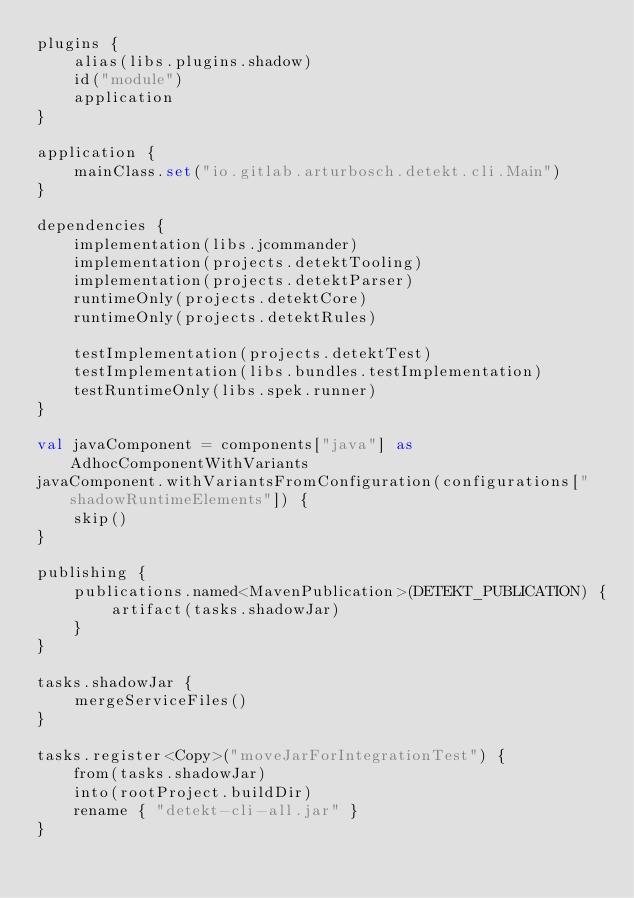Convert code to text. <code><loc_0><loc_0><loc_500><loc_500><_Kotlin_>plugins {
    alias(libs.plugins.shadow)
    id("module")
    application
}

application {
    mainClass.set("io.gitlab.arturbosch.detekt.cli.Main")
}

dependencies {
    implementation(libs.jcommander)
    implementation(projects.detektTooling)
    implementation(projects.detektParser)
    runtimeOnly(projects.detektCore)
    runtimeOnly(projects.detektRules)

    testImplementation(projects.detektTest)
    testImplementation(libs.bundles.testImplementation)
    testRuntimeOnly(libs.spek.runner)
}

val javaComponent = components["java"] as AdhocComponentWithVariants
javaComponent.withVariantsFromConfiguration(configurations["shadowRuntimeElements"]) {
    skip()
}

publishing {
    publications.named<MavenPublication>(DETEKT_PUBLICATION) {
        artifact(tasks.shadowJar)
    }
}

tasks.shadowJar {
    mergeServiceFiles()
}

tasks.register<Copy>("moveJarForIntegrationTest") {
    from(tasks.shadowJar)
    into(rootProject.buildDir)
    rename { "detekt-cli-all.jar" }
}
</code> 